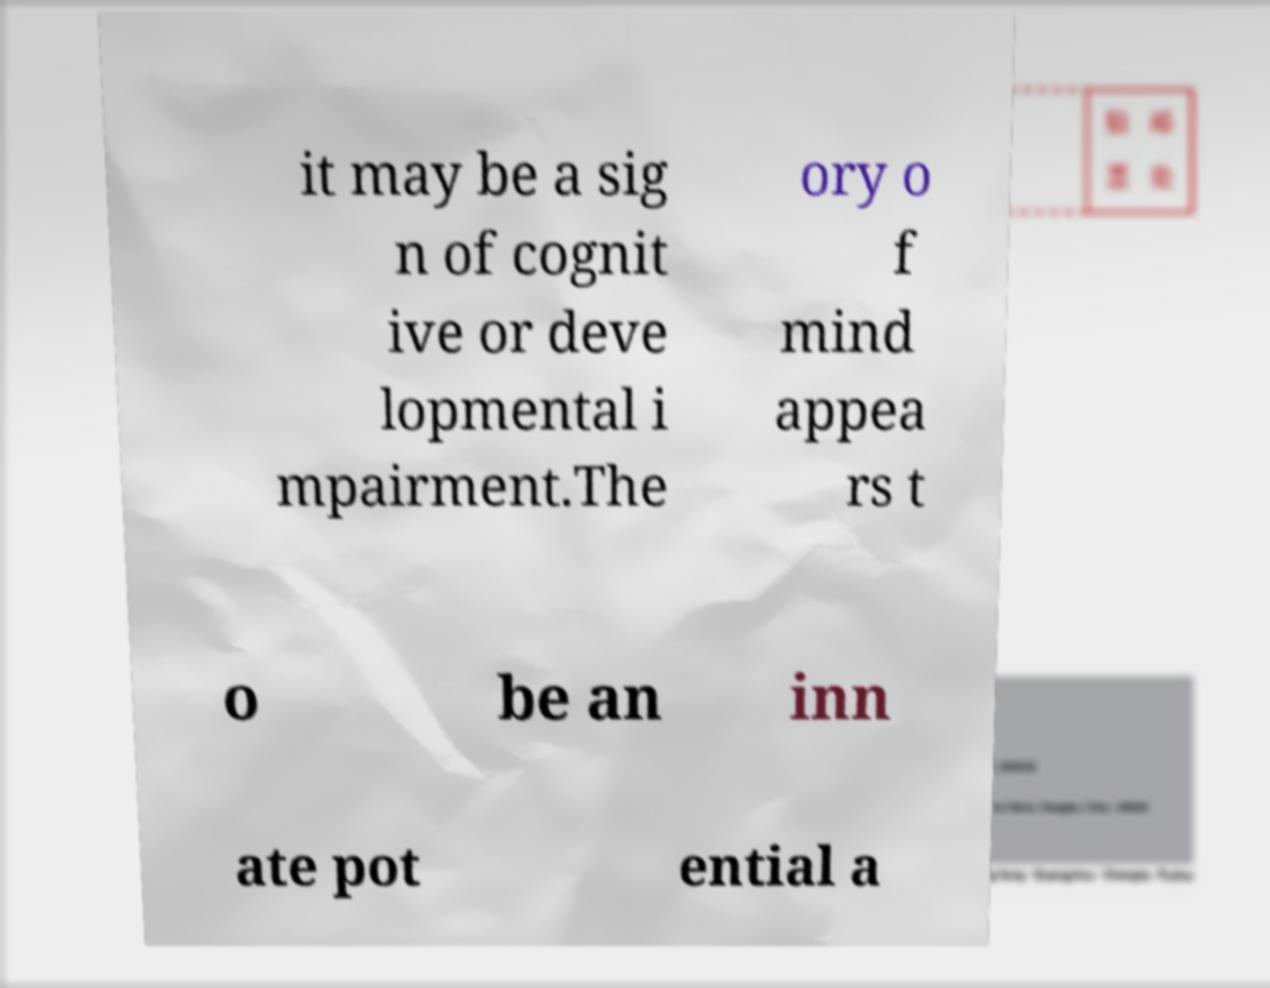What messages or text are displayed in this image? I need them in a readable, typed format. it may be a sig n of cognit ive or deve lopmental i mpairment.The ory o f mind appea rs t o be an inn ate pot ential a 